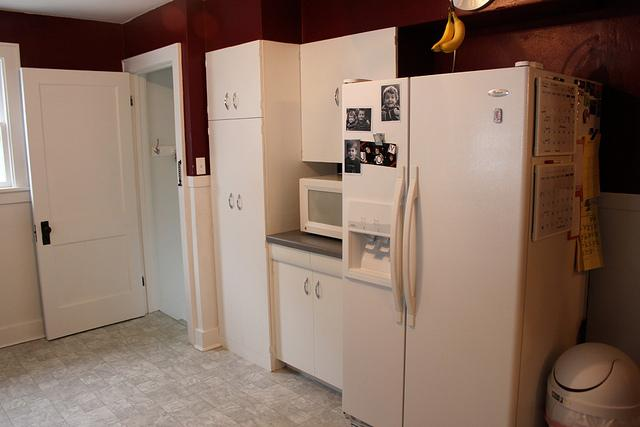What is the state of the bananas? good 